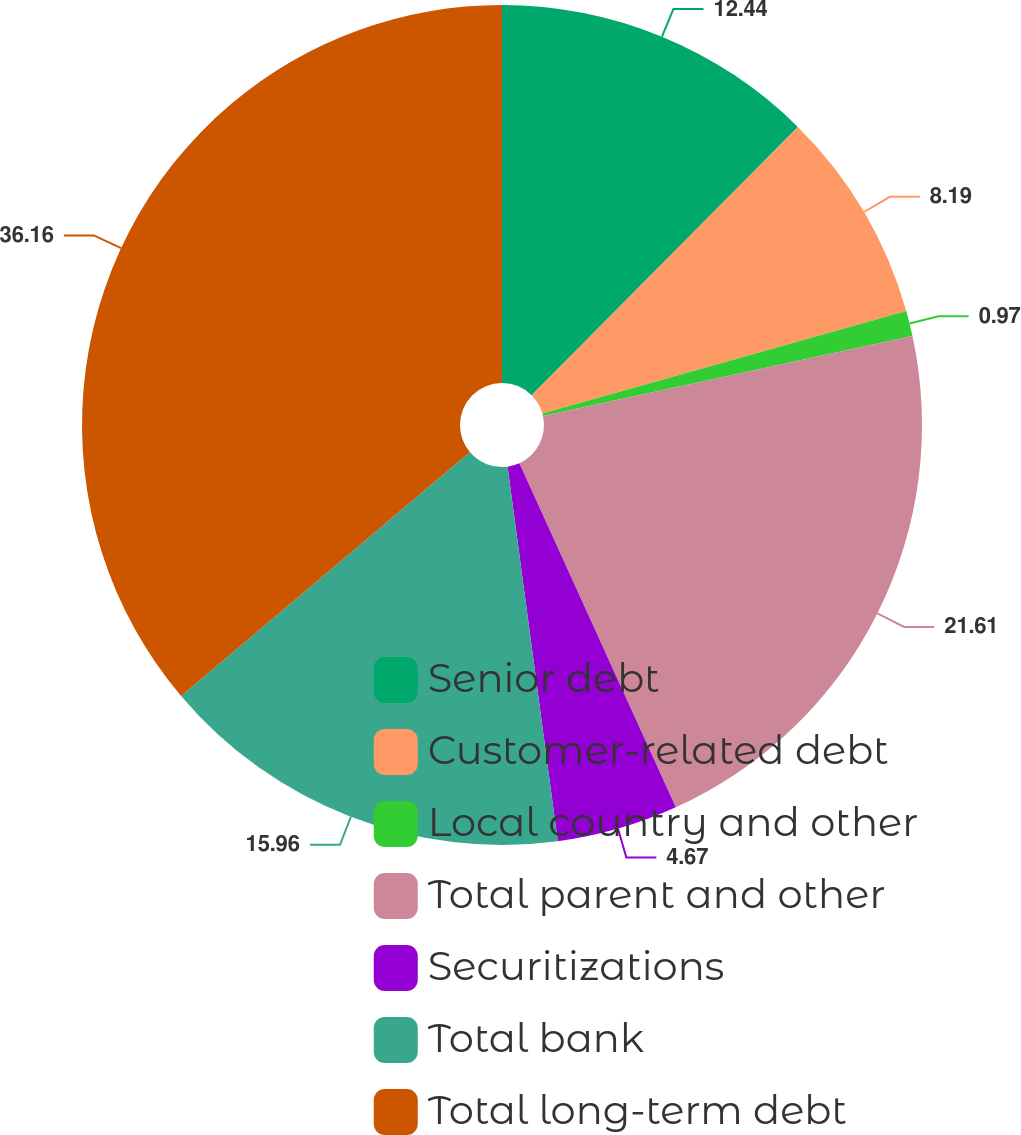Convert chart. <chart><loc_0><loc_0><loc_500><loc_500><pie_chart><fcel>Senior debt<fcel>Customer-related debt<fcel>Local country and other<fcel>Total parent and other<fcel>Securitizations<fcel>Total bank<fcel>Total long-term debt<nl><fcel>12.44%<fcel>8.19%<fcel>0.97%<fcel>21.61%<fcel>4.67%<fcel>15.96%<fcel>36.16%<nl></chart> 